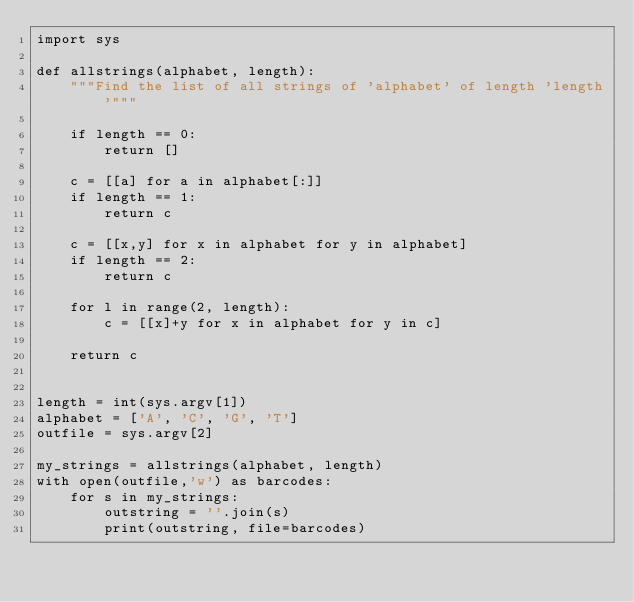<code> <loc_0><loc_0><loc_500><loc_500><_Python_>import sys

def allstrings(alphabet, length):
    """Find the list of all strings of 'alphabet' of length 'length'"""

    if length == 0: 
        return []

    c = [[a] for a in alphabet[:]]
    if length == 1: 
        return c

    c = [[x,y] for x in alphabet for y in alphabet]
    if length == 2: 
        return c

    for l in range(2, length):
        c = [[x]+y for x in alphabet for y in c]
        
    return c


length = int(sys.argv[1])
alphabet = ['A', 'C', 'G', 'T']
outfile = sys.argv[2]

my_strings = allstrings(alphabet, length)
with open(outfile,'w') as barcodes:
    for s in my_strings:
        outstring = ''.join(s)
        print(outstring, file=barcodes)	
</code> 